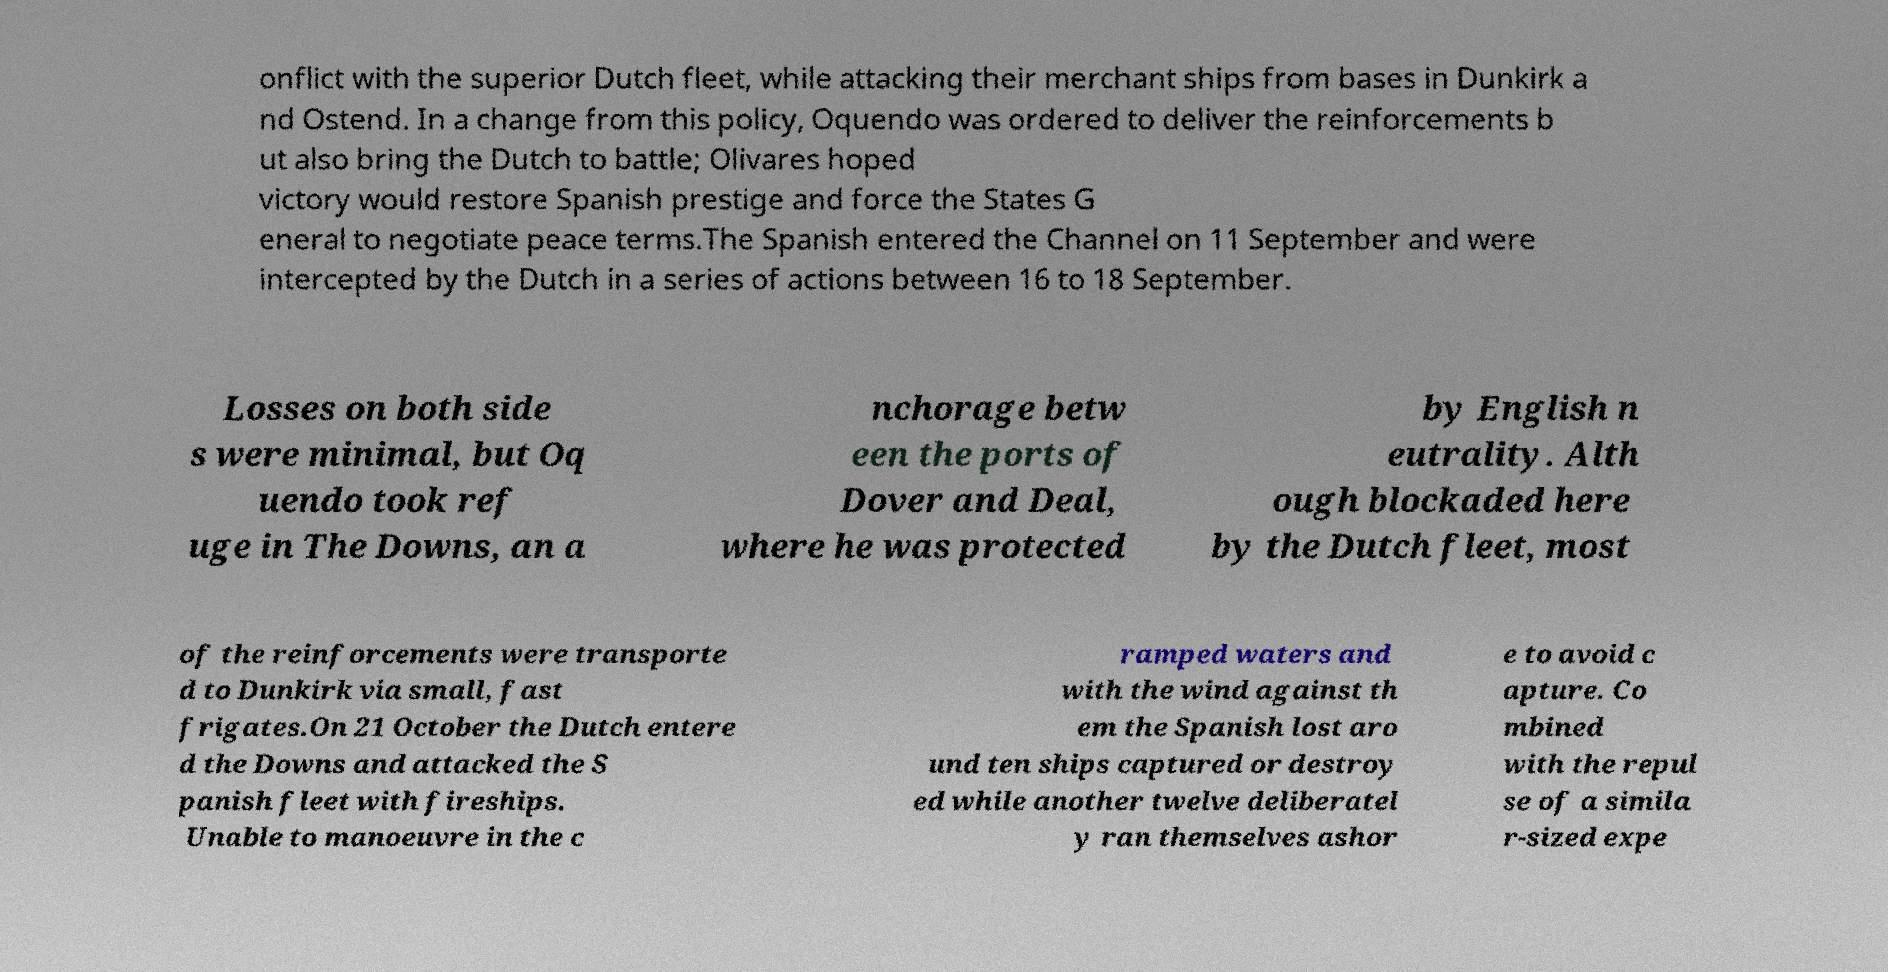What messages or text are displayed in this image? I need them in a readable, typed format. onflict with the superior Dutch fleet, while attacking their merchant ships from bases in Dunkirk a nd Ostend. In a change from this policy, Oquendo was ordered to deliver the reinforcements b ut also bring the Dutch to battle; Olivares hoped victory would restore Spanish prestige and force the States G eneral to negotiate peace terms.The Spanish entered the Channel on 11 September and were intercepted by the Dutch in a series of actions between 16 to 18 September. Losses on both side s were minimal, but Oq uendo took ref uge in The Downs, an a nchorage betw een the ports of Dover and Deal, where he was protected by English n eutrality. Alth ough blockaded here by the Dutch fleet, most of the reinforcements were transporte d to Dunkirk via small, fast frigates.On 21 October the Dutch entere d the Downs and attacked the S panish fleet with fireships. Unable to manoeuvre in the c ramped waters and with the wind against th em the Spanish lost aro und ten ships captured or destroy ed while another twelve deliberatel y ran themselves ashor e to avoid c apture. Co mbined with the repul se of a simila r-sized expe 